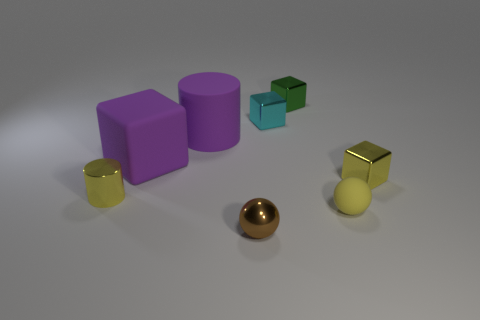How many spheres are tiny blue matte objects or purple things?
Your answer should be compact. 0. What material is the large thing that is the same color as the matte cylinder?
Your answer should be compact. Rubber. Do the tiny metal cylinder and the cylinder that is behind the tiny yellow metal cube have the same color?
Keep it short and to the point. No. The large matte cube is what color?
Provide a succinct answer. Purple. What number of things are big cubes or small red spheres?
Offer a terse response. 1. What is the material of the purple object that is the same size as the purple block?
Your answer should be compact. Rubber. There is a purple rubber cylinder that is behind the big purple cube; what size is it?
Offer a terse response. Large. What is the tiny green block made of?
Offer a terse response. Metal. What number of objects are either large purple rubber objects that are behind the big block or tiny cyan metal things to the right of the brown object?
Your answer should be compact. 2. What number of other things are the same color as the big cube?
Ensure brevity in your answer.  1. 